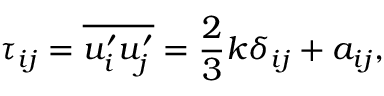Convert formula to latex. <formula><loc_0><loc_0><loc_500><loc_500>\tau _ { i j } = \overline { { u _ { i } ^ { \prime } u _ { j } ^ { \prime } } } = \frac { 2 } { 3 } k \delta _ { i j } + a _ { i j } ,</formula> 